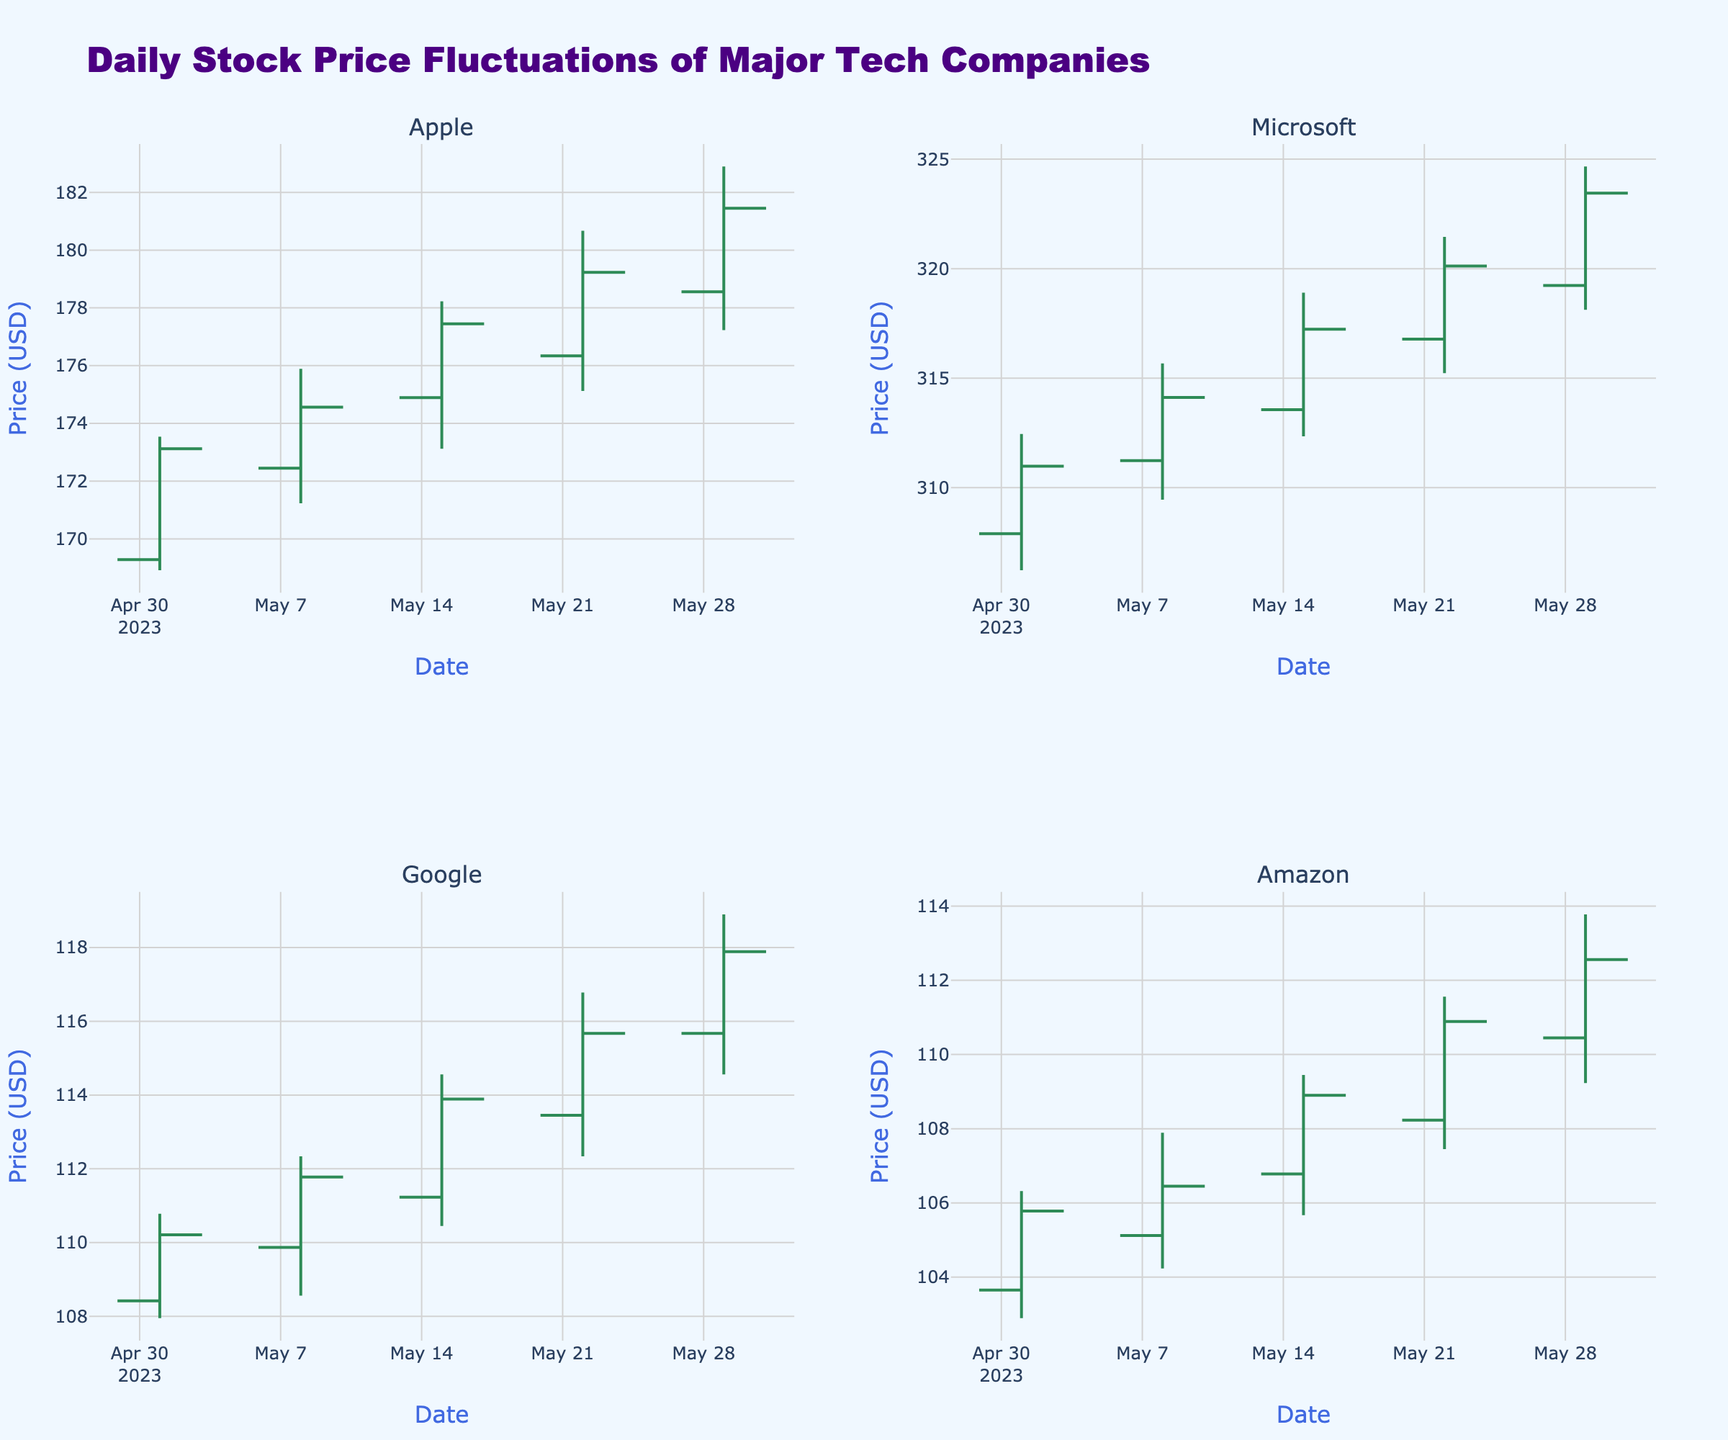What is the title of the figure? The title is located at the top of the figure. It is typically in a larger font size and describes the main content of the plot.
Answer: Daily Stock Price Fluctuations of Major Tech Companies Which company's stock had the highest closing price on May 29, 2023? By looking at the closing prices for May 29, 2023, you can find the highest value for each company and compare them.
Answer: Microsoft How many data points are there for each company? Each data point represents a date in the dataset. From the figure, it can be observed that each company has data points for each Monday in May. Counting these dates, we get 5 data points (one for each Monday).
Answer: 5 Which company showed the most significant increase in closing price from May 1, 2023, to May 29, 2023? Calculate the difference between the closing prices on May 1 and May 29 for each company. Then, compare these differences to find the largest positive change.
Answer: Apple On which date did Google’s stock have its highest closing price? Refer to the Google subplot and look for the highest position of the closing price for all the given dates.
Answer: May 29, 2023 What is the average closing price of Amazon's stock over the month of May 2023? Add up all the closing prices of Amazon for May and divide by the number of data points (5).
Answer: (105.78 + 106.45 + 108.90 + 110.89 + 112.56) / 5 = 108.916 Between Microsoft and Apple, which company had the higher closing price on May 22, 2023? Compare the closing price values for both companies on the specific date.
Answer: Microsoft What is the range of Apple’s stock price on May 15, 2023? Subtract the lowest price from the highest price for Apple on May 15, 2023.
Answer: 178.23 - 173.12 = 5.11 Which company had the smallest fluctuation in its stock price on May 8, 2023? Calculate the difference between the high and low prices for each company and find the smallest value.
Answer: Google What pattern can you observe across all companies in terms of stock price movement over the month? Look for general trends in the plots, such as whether stock prices are generally increasing, decreasing, or fluctuating without a clear trend.
Answer: Generally increasing 